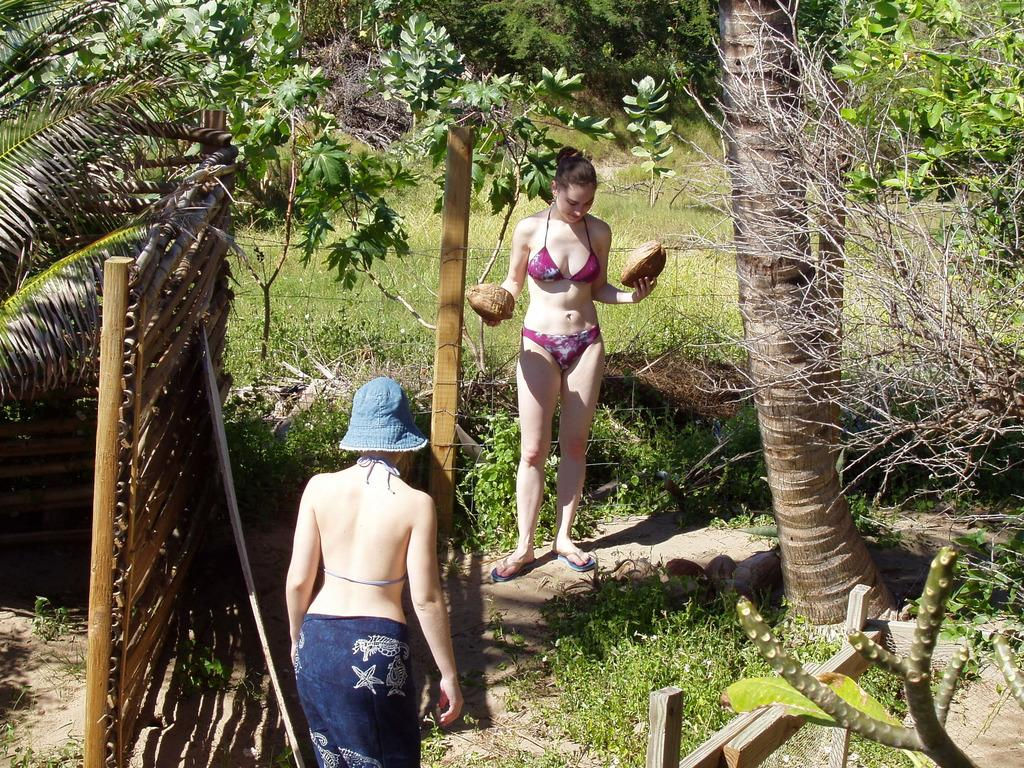How many people are in the image? There are two women in the image. What can be seen in the background of the image? There is grass and trees in the background of the image. What type of smell can be detected in the image? There is no information about smells in the image, so it cannot be determined from the image. 